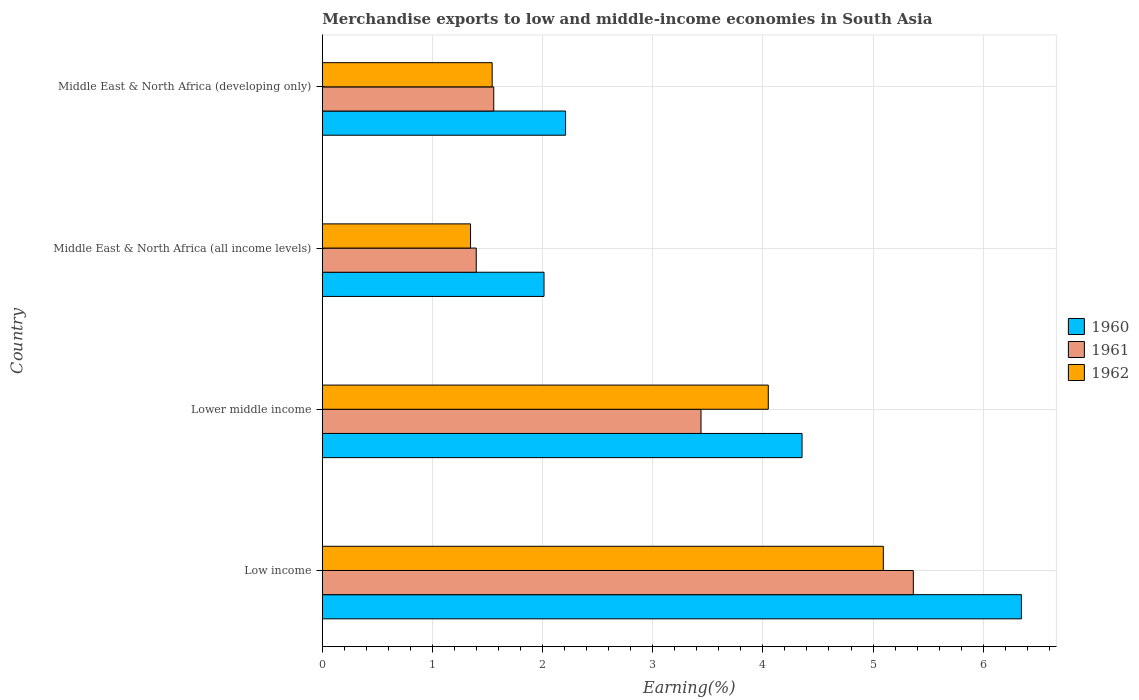How many groups of bars are there?
Make the answer very short. 4. Are the number of bars per tick equal to the number of legend labels?
Offer a terse response. Yes. Are the number of bars on each tick of the Y-axis equal?
Offer a very short reply. Yes. What is the label of the 3rd group of bars from the top?
Make the answer very short. Lower middle income. In how many cases, is the number of bars for a given country not equal to the number of legend labels?
Offer a terse response. 0. What is the percentage of amount earned from merchandise exports in 1961 in Lower middle income?
Give a very brief answer. 3.44. Across all countries, what is the maximum percentage of amount earned from merchandise exports in 1962?
Your answer should be very brief. 5.09. Across all countries, what is the minimum percentage of amount earned from merchandise exports in 1962?
Provide a succinct answer. 1.35. In which country was the percentage of amount earned from merchandise exports in 1962 minimum?
Provide a short and direct response. Middle East & North Africa (all income levels). What is the total percentage of amount earned from merchandise exports in 1960 in the graph?
Ensure brevity in your answer.  14.92. What is the difference between the percentage of amount earned from merchandise exports in 1962 in Lower middle income and that in Middle East & North Africa (developing only)?
Ensure brevity in your answer.  2.51. What is the difference between the percentage of amount earned from merchandise exports in 1960 in Low income and the percentage of amount earned from merchandise exports in 1961 in Middle East & North Africa (all income levels)?
Offer a very short reply. 4.95. What is the average percentage of amount earned from merchandise exports in 1962 per country?
Your answer should be compact. 3.01. What is the difference between the percentage of amount earned from merchandise exports in 1960 and percentage of amount earned from merchandise exports in 1962 in Low income?
Ensure brevity in your answer.  1.25. What is the ratio of the percentage of amount earned from merchandise exports in 1960 in Low income to that in Lower middle income?
Your answer should be compact. 1.46. Is the difference between the percentage of amount earned from merchandise exports in 1960 in Low income and Middle East & North Africa (developing only) greater than the difference between the percentage of amount earned from merchandise exports in 1962 in Low income and Middle East & North Africa (developing only)?
Ensure brevity in your answer.  Yes. What is the difference between the highest and the second highest percentage of amount earned from merchandise exports in 1962?
Keep it short and to the point. 1.04. What is the difference between the highest and the lowest percentage of amount earned from merchandise exports in 1961?
Offer a terse response. 3.97. In how many countries, is the percentage of amount earned from merchandise exports in 1962 greater than the average percentage of amount earned from merchandise exports in 1962 taken over all countries?
Offer a terse response. 2. Is the sum of the percentage of amount earned from merchandise exports in 1962 in Lower middle income and Middle East & North Africa (developing only) greater than the maximum percentage of amount earned from merchandise exports in 1961 across all countries?
Your answer should be compact. Yes. What does the 2nd bar from the top in Middle East & North Africa (all income levels) represents?
Ensure brevity in your answer.  1961. What does the 3rd bar from the bottom in Lower middle income represents?
Offer a terse response. 1962. Is it the case that in every country, the sum of the percentage of amount earned from merchandise exports in 1962 and percentage of amount earned from merchandise exports in 1961 is greater than the percentage of amount earned from merchandise exports in 1960?
Your answer should be compact. Yes. How many countries are there in the graph?
Your answer should be compact. 4. Are the values on the major ticks of X-axis written in scientific E-notation?
Make the answer very short. No. Does the graph contain grids?
Offer a terse response. Yes. Where does the legend appear in the graph?
Your answer should be very brief. Center right. How many legend labels are there?
Make the answer very short. 3. How are the legend labels stacked?
Keep it short and to the point. Vertical. What is the title of the graph?
Offer a very short reply. Merchandise exports to low and middle-income economies in South Asia. Does "2002" appear as one of the legend labels in the graph?
Provide a succinct answer. No. What is the label or title of the X-axis?
Provide a short and direct response. Earning(%). What is the Earning(%) of 1960 in Low income?
Provide a succinct answer. 6.35. What is the Earning(%) in 1961 in Low income?
Provide a succinct answer. 5.37. What is the Earning(%) in 1962 in Low income?
Your answer should be very brief. 5.09. What is the Earning(%) of 1960 in Lower middle income?
Offer a terse response. 4.36. What is the Earning(%) of 1961 in Lower middle income?
Offer a very short reply. 3.44. What is the Earning(%) of 1962 in Lower middle income?
Provide a short and direct response. 4.05. What is the Earning(%) of 1960 in Middle East & North Africa (all income levels)?
Your answer should be compact. 2.01. What is the Earning(%) in 1961 in Middle East & North Africa (all income levels)?
Give a very brief answer. 1.4. What is the Earning(%) in 1962 in Middle East & North Africa (all income levels)?
Provide a short and direct response. 1.35. What is the Earning(%) in 1960 in Middle East & North Africa (developing only)?
Your answer should be very brief. 2.21. What is the Earning(%) of 1961 in Middle East & North Africa (developing only)?
Provide a succinct answer. 1.56. What is the Earning(%) in 1962 in Middle East & North Africa (developing only)?
Make the answer very short. 1.54. Across all countries, what is the maximum Earning(%) of 1960?
Keep it short and to the point. 6.35. Across all countries, what is the maximum Earning(%) in 1961?
Your response must be concise. 5.37. Across all countries, what is the maximum Earning(%) of 1962?
Provide a succinct answer. 5.09. Across all countries, what is the minimum Earning(%) of 1960?
Make the answer very short. 2.01. Across all countries, what is the minimum Earning(%) in 1961?
Keep it short and to the point. 1.4. Across all countries, what is the minimum Earning(%) of 1962?
Make the answer very short. 1.35. What is the total Earning(%) of 1960 in the graph?
Make the answer very short. 14.92. What is the total Earning(%) in 1961 in the graph?
Offer a very short reply. 11.76. What is the total Earning(%) in 1962 in the graph?
Offer a terse response. 12.03. What is the difference between the Earning(%) of 1960 in Low income and that in Lower middle income?
Make the answer very short. 1.99. What is the difference between the Earning(%) in 1961 in Low income and that in Lower middle income?
Keep it short and to the point. 1.93. What is the difference between the Earning(%) in 1962 in Low income and that in Lower middle income?
Give a very brief answer. 1.04. What is the difference between the Earning(%) of 1960 in Low income and that in Middle East & North Africa (all income levels)?
Keep it short and to the point. 4.33. What is the difference between the Earning(%) of 1961 in Low income and that in Middle East & North Africa (all income levels)?
Provide a succinct answer. 3.97. What is the difference between the Earning(%) in 1962 in Low income and that in Middle East & North Africa (all income levels)?
Offer a very short reply. 3.75. What is the difference between the Earning(%) of 1960 in Low income and that in Middle East & North Africa (developing only)?
Provide a short and direct response. 4.14. What is the difference between the Earning(%) of 1961 in Low income and that in Middle East & North Africa (developing only)?
Your answer should be very brief. 3.81. What is the difference between the Earning(%) in 1962 in Low income and that in Middle East & North Africa (developing only)?
Offer a very short reply. 3.55. What is the difference between the Earning(%) of 1960 in Lower middle income and that in Middle East & North Africa (all income levels)?
Offer a very short reply. 2.34. What is the difference between the Earning(%) in 1961 in Lower middle income and that in Middle East & North Africa (all income levels)?
Offer a very short reply. 2.04. What is the difference between the Earning(%) of 1962 in Lower middle income and that in Middle East & North Africa (all income levels)?
Provide a succinct answer. 2.7. What is the difference between the Earning(%) of 1960 in Lower middle income and that in Middle East & North Africa (developing only)?
Give a very brief answer. 2.15. What is the difference between the Earning(%) in 1961 in Lower middle income and that in Middle East & North Africa (developing only)?
Provide a short and direct response. 1.88. What is the difference between the Earning(%) of 1962 in Lower middle income and that in Middle East & North Africa (developing only)?
Give a very brief answer. 2.51. What is the difference between the Earning(%) in 1960 in Middle East & North Africa (all income levels) and that in Middle East & North Africa (developing only)?
Your answer should be compact. -0.2. What is the difference between the Earning(%) in 1961 in Middle East & North Africa (all income levels) and that in Middle East & North Africa (developing only)?
Ensure brevity in your answer.  -0.16. What is the difference between the Earning(%) of 1962 in Middle East & North Africa (all income levels) and that in Middle East & North Africa (developing only)?
Give a very brief answer. -0.2. What is the difference between the Earning(%) of 1960 in Low income and the Earning(%) of 1961 in Lower middle income?
Provide a succinct answer. 2.91. What is the difference between the Earning(%) of 1960 in Low income and the Earning(%) of 1962 in Lower middle income?
Your answer should be very brief. 2.3. What is the difference between the Earning(%) of 1961 in Low income and the Earning(%) of 1962 in Lower middle income?
Your answer should be very brief. 1.32. What is the difference between the Earning(%) in 1960 in Low income and the Earning(%) in 1961 in Middle East & North Africa (all income levels)?
Offer a very short reply. 4.95. What is the difference between the Earning(%) in 1960 in Low income and the Earning(%) in 1962 in Middle East & North Africa (all income levels)?
Make the answer very short. 5. What is the difference between the Earning(%) in 1961 in Low income and the Earning(%) in 1962 in Middle East & North Africa (all income levels)?
Provide a short and direct response. 4.02. What is the difference between the Earning(%) in 1960 in Low income and the Earning(%) in 1961 in Middle East & North Africa (developing only)?
Your response must be concise. 4.79. What is the difference between the Earning(%) in 1960 in Low income and the Earning(%) in 1962 in Middle East & North Africa (developing only)?
Keep it short and to the point. 4.81. What is the difference between the Earning(%) of 1961 in Low income and the Earning(%) of 1962 in Middle East & North Africa (developing only)?
Your answer should be very brief. 3.82. What is the difference between the Earning(%) of 1960 in Lower middle income and the Earning(%) of 1961 in Middle East & North Africa (all income levels)?
Make the answer very short. 2.96. What is the difference between the Earning(%) in 1960 in Lower middle income and the Earning(%) in 1962 in Middle East & North Africa (all income levels)?
Provide a succinct answer. 3.01. What is the difference between the Earning(%) of 1961 in Lower middle income and the Earning(%) of 1962 in Middle East & North Africa (all income levels)?
Ensure brevity in your answer.  2.09. What is the difference between the Earning(%) of 1960 in Lower middle income and the Earning(%) of 1961 in Middle East & North Africa (developing only)?
Your response must be concise. 2.8. What is the difference between the Earning(%) in 1960 in Lower middle income and the Earning(%) in 1962 in Middle East & North Africa (developing only)?
Give a very brief answer. 2.81. What is the difference between the Earning(%) of 1961 in Lower middle income and the Earning(%) of 1962 in Middle East & North Africa (developing only)?
Provide a succinct answer. 1.9. What is the difference between the Earning(%) in 1960 in Middle East & North Africa (all income levels) and the Earning(%) in 1961 in Middle East & North Africa (developing only)?
Keep it short and to the point. 0.46. What is the difference between the Earning(%) of 1960 in Middle East & North Africa (all income levels) and the Earning(%) of 1962 in Middle East & North Africa (developing only)?
Offer a terse response. 0.47. What is the difference between the Earning(%) in 1961 in Middle East & North Africa (all income levels) and the Earning(%) in 1962 in Middle East & North Africa (developing only)?
Keep it short and to the point. -0.14. What is the average Earning(%) in 1960 per country?
Offer a very short reply. 3.73. What is the average Earning(%) of 1961 per country?
Offer a very short reply. 2.94. What is the average Earning(%) in 1962 per country?
Ensure brevity in your answer.  3.01. What is the difference between the Earning(%) of 1960 and Earning(%) of 1961 in Low income?
Provide a succinct answer. 0.98. What is the difference between the Earning(%) of 1960 and Earning(%) of 1962 in Low income?
Provide a succinct answer. 1.25. What is the difference between the Earning(%) of 1961 and Earning(%) of 1962 in Low income?
Make the answer very short. 0.27. What is the difference between the Earning(%) in 1960 and Earning(%) in 1961 in Lower middle income?
Keep it short and to the point. 0.92. What is the difference between the Earning(%) of 1960 and Earning(%) of 1962 in Lower middle income?
Give a very brief answer. 0.31. What is the difference between the Earning(%) of 1961 and Earning(%) of 1962 in Lower middle income?
Provide a succinct answer. -0.61. What is the difference between the Earning(%) of 1960 and Earning(%) of 1961 in Middle East & North Africa (all income levels)?
Your answer should be compact. 0.62. What is the difference between the Earning(%) in 1960 and Earning(%) in 1962 in Middle East & North Africa (all income levels)?
Your response must be concise. 0.67. What is the difference between the Earning(%) in 1961 and Earning(%) in 1962 in Middle East & North Africa (all income levels)?
Keep it short and to the point. 0.05. What is the difference between the Earning(%) in 1960 and Earning(%) in 1961 in Middle East & North Africa (developing only)?
Make the answer very short. 0.65. What is the difference between the Earning(%) in 1960 and Earning(%) in 1962 in Middle East & North Africa (developing only)?
Your response must be concise. 0.67. What is the difference between the Earning(%) in 1961 and Earning(%) in 1962 in Middle East & North Africa (developing only)?
Your answer should be very brief. 0.01. What is the ratio of the Earning(%) in 1960 in Low income to that in Lower middle income?
Offer a very short reply. 1.46. What is the ratio of the Earning(%) in 1961 in Low income to that in Lower middle income?
Your response must be concise. 1.56. What is the ratio of the Earning(%) in 1962 in Low income to that in Lower middle income?
Keep it short and to the point. 1.26. What is the ratio of the Earning(%) of 1960 in Low income to that in Middle East & North Africa (all income levels)?
Provide a succinct answer. 3.15. What is the ratio of the Earning(%) of 1961 in Low income to that in Middle East & North Africa (all income levels)?
Your answer should be compact. 3.84. What is the ratio of the Earning(%) in 1962 in Low income to that in Middle East & North Africa (all income levels)?
Provide a short and direct response. 3.78. What is the ratio of the Earning(%) of 1960 in Low income to that in Middle East & North Africa (developing only)?
Offer a terse response. 2.87. What is the ratio of the Earning(%) of 1961 in Low income to that in Middle East & North Africa (developing only)?
Your response must be concise. 3.45. What is the ratio of the Earning(%) of 1962 in Low income to that in Middle East & North Africa (developing only)?
Your response must be concise. 3.3. What is the ratio of the Earning(%) of 1960 in Lower middle income to that in Middle East & North Africa (all income levels)?
Offer a terse response. 2.16. What is the ratio of the Earning(%) in 1961 in Lower middle income to that in Middle East & North Africa (all income levels)?
Offer a very short reply. 2.46. What is the ratio of the Earning(%) in 1962 in Lower middle income to that in Middle East & North Africa (all income levels)?
Your answer should be very brief. 3.01. What is the ratio of the Earning(%) of 1960 in Lower middle income to that in Middle East & North Africa (developing only)?
Provide a succinct answer. 1.97. What is the ratio of the Earning(%) in 1961 in Lower middle income to that in Middle East & North Africa (developing only)?
Offer a terse response. 2.21. What is the ratio of the Earning(%) of 1962 in Lower middle income to that in Middle East & North Africa (developing only)?
Your response must be concise. 2.63. What is the ratio of the Earning(%) of 1960 in Middle East & North Africa (all income levels) to that in Middle East & North Africa (developing only)?
Your answer should be compact. 0.91. What is the ratio of the Earning(%) in 1961 in Middle East & North Africa (all income levels) to that in Middle East & North Africa (developing only)?
Offer a terse response. 0.9. What is the ratio of the Earning(%) in 1962 in Middle East & North Africa (all income levels) to that in Middle East & North Africa (developing only)?
Your response must be concise. 0.87. What is the difference between the highest and the second highest Earning(%) of 1960?
Ensure brevity in your answer.  1.99. What is the difference between the highest and the second highest Earning(%) of 1961?
Give a very brief answer. 1.93. What is the difference between the highest and the second highest Earning(%) in 1962?
Provide a succinct answer. 1.04. What is the difference between the highest and the lowest Earning(%) in 1960?
Provide a succinct answer. 4.33. What is the difference between the highest and the lowest Earning(%) of 1961?
Your answer should be compact. 3.97. What is the difference between the highest and the lowest Earning(%) of 1962?
Your answer should be compact. 3.75. 